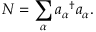Convert formula to latex. <formula><loc_0><loc_0><loc_500><loc_500>N = \sum _ { \alpha } { a _ { \alpha } } ^ { \dagger } a _ { \alpha } .</formula> 